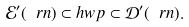<formula> <loc_0><loc_0><loc_500><loc_500>\mathcal { E } ^ { \prime } ( \ r n ) \subset h w p \subset \mathcal { D } ^ { \prime } ( \ r n ) .</formula> 